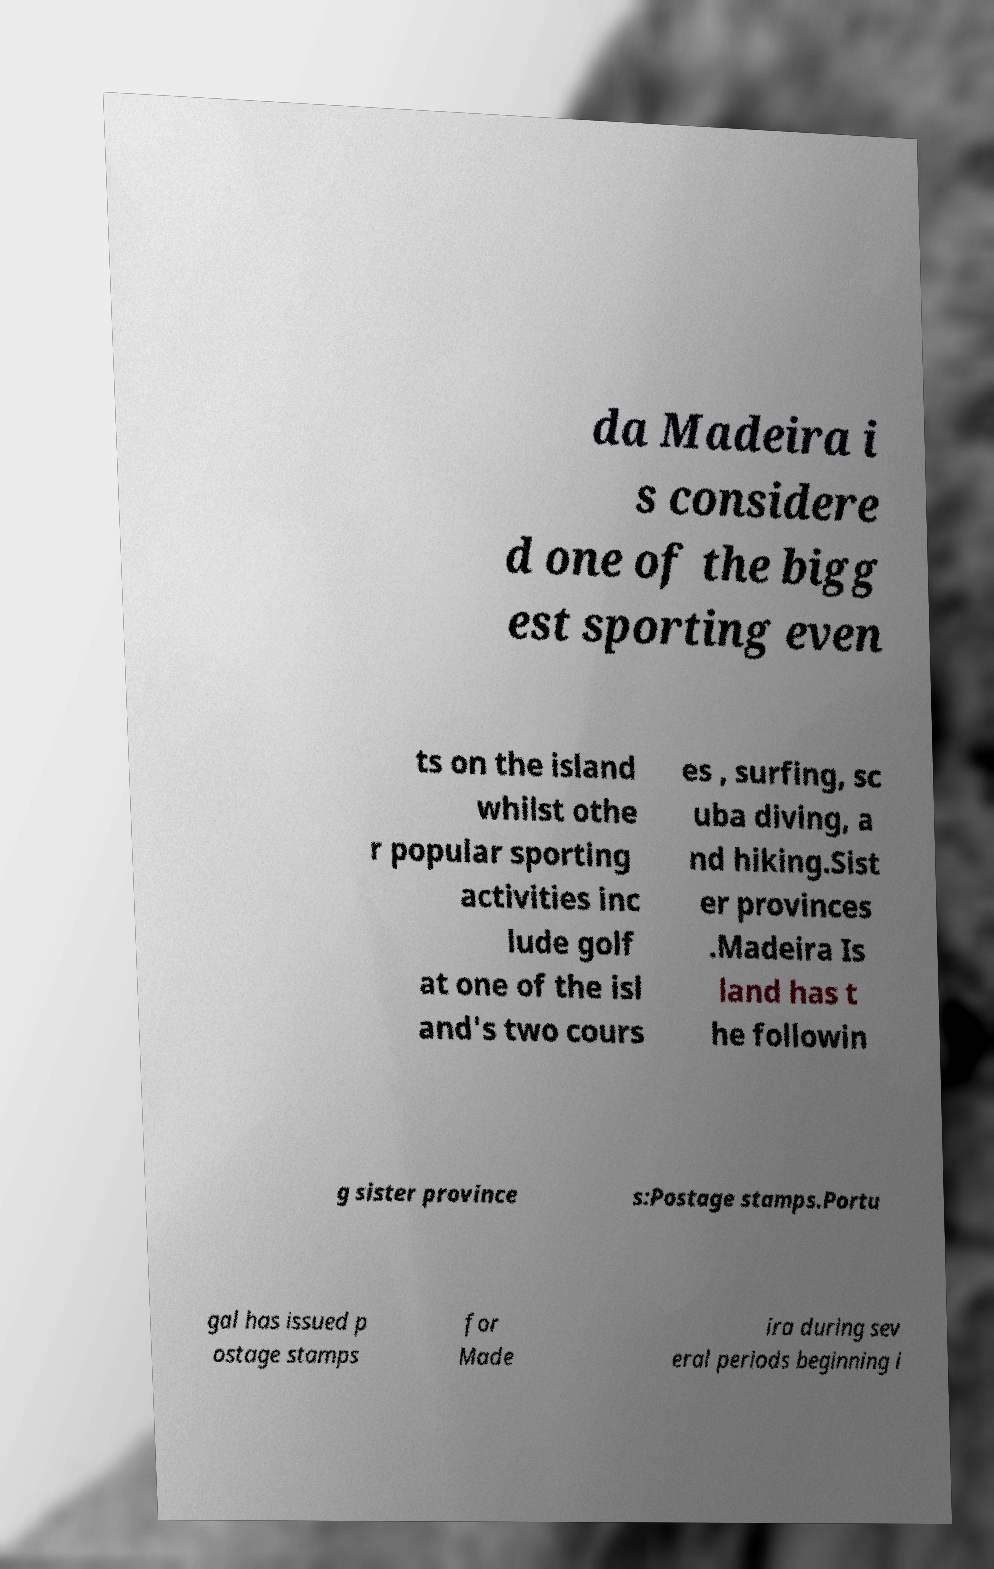I need the written content from this picture converted into text. Can you do that? da Madeira i s considere d one of the bigg est sporting even ts on the island whilst othe r popular sporting activities inc lude golf at one of the isl and's two cours es , surfing, sc uba diving, a nd hiking.Sist er provinces .Madeira Is land has t he followin g sister province s:Postage stamps.Portu gal has issued p ostage stamps for Made ira during sev eral periods beginning i 